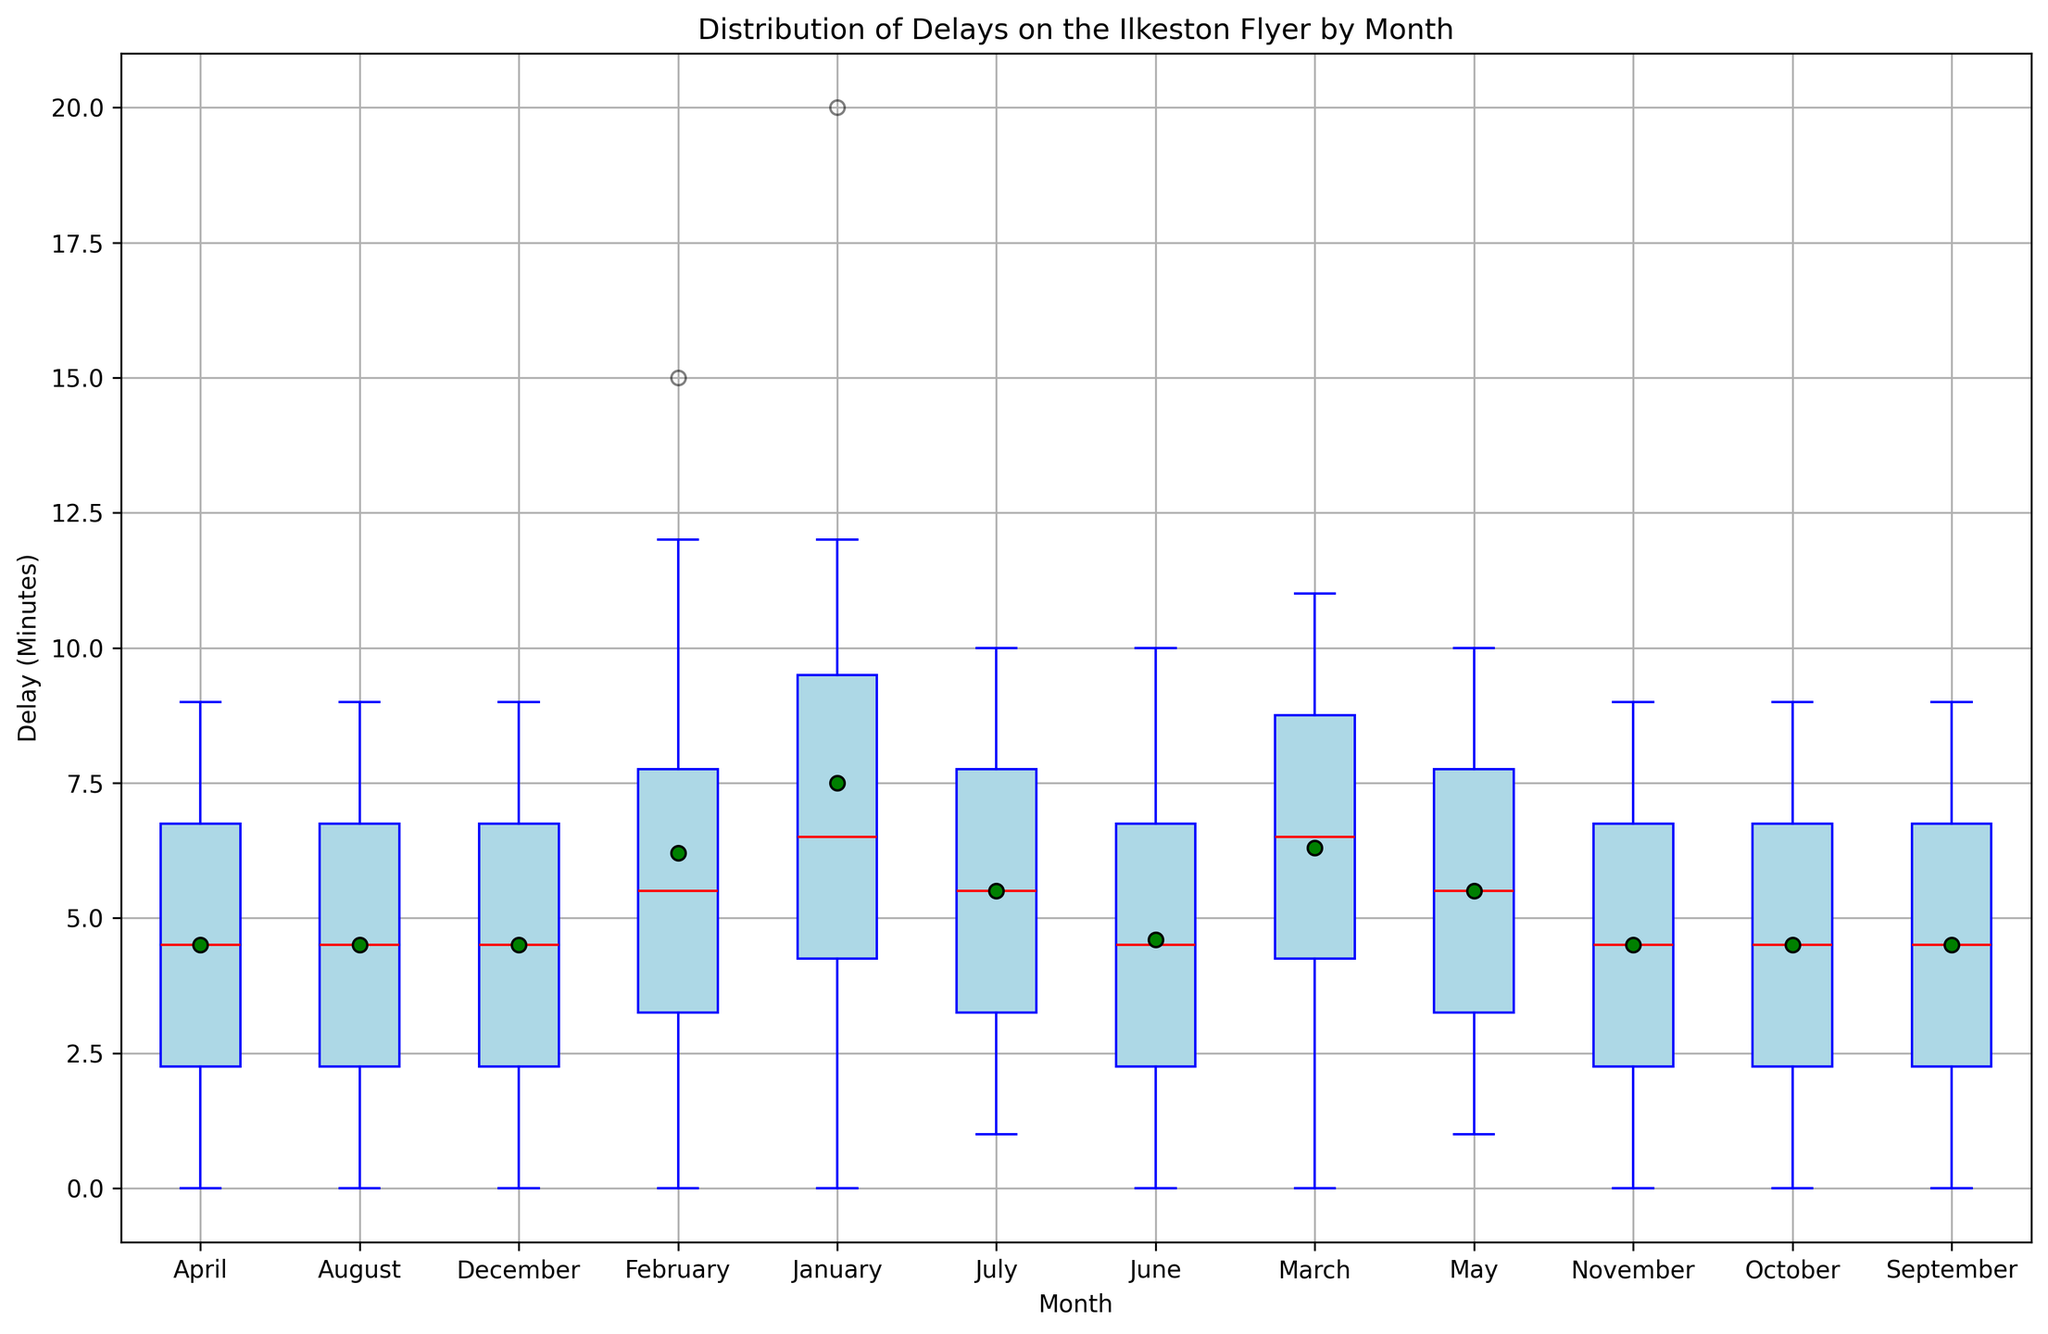What is the median delay in March? The median is indicated by the red line in each box. Looking at March, the red line is at 6 minutes.
Answer: 6 Which month had the highest mean delay? The mean delay is represented by a green dot within each box. By observing the plot, January has the green dot at the highest value, which confirms that January has the highest mean delay.
Answer: January Which month has the smallest interquartile range (IQR) for delays? The interquartile range is the range between the bottom and top of the blue box (the first quartile and third quartile). By comparing the lengths of the boxes, May has the smallest IQR.
Answer: May Are there any months with outliers in the delay times, and if so, which months are they? Outliers are indicated by orange circles outside the whiskers of the box plot. Observing the plot, January has an outlier.
Answer: January Which month has the largest range of delays? The range of delays can be seen from the whiskers (the lines extending from the top and bottom of the box). The longest whisker length is in January.
Answer: January Is there any month where the minimum delay time is zero? The minimum delay time is where the bottom whisker or the bottom of the box plot touches the x-axis at zero minutes. Observing the figure, multiple months including January, February, March, April, June, August, September, October, and November have a minimum delay time of zero.
Answer: January, February, March, April, June, August, September, October, November Which months have the median delay greater than 4 minutes? The median delay is the red line in each box plot. The months where this red line is above the 4-minute mark include January, February, March, May, and December.
Answer: January, February, March, May, December How does the median delay in December compare to the median delay in June? The median delay for December is indicated by the red line at 4 minutes, and for June, it's at 4 minutes as well. Thus, the median delays are equal.
Answer: They are equal What is the range of delay times in July? The range is the difference between the maximum and minimum values, marked by the whiskers. In July, the maximum delay is 10 minutes and the minimum delay is 1 minute. Therefore, the range is 10 - 1 = 9 minutes.
Answer: 9 minutes During which month can you expect the most consistent delay times (smallest IQR)? Looking at the boxes indicating the IQR, May has the most consistent delay times indicated by the smallest IQR.
Answer: May 